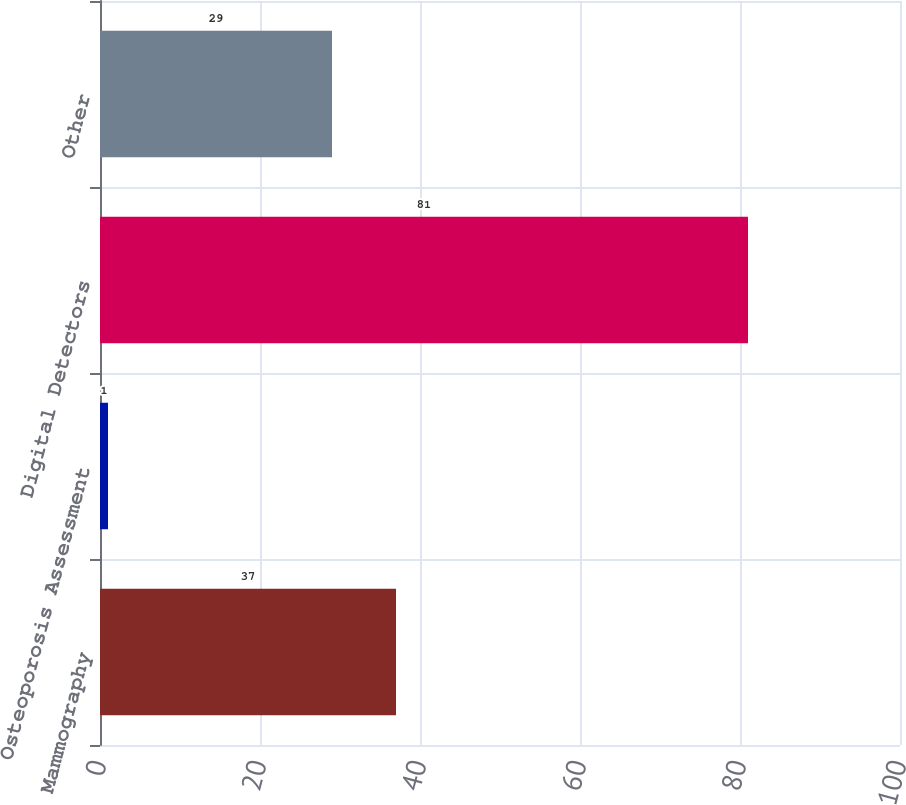Convert chart to OTSL. <chart><loc_0><loc_0><loc_500><loc_500><bar_chart><fcel>Mammography<fcel>Osteoporosis Assessment<fcel>Digital Detectors<fcel>Other<nl><fcel>37<fcel>1<fcel>81<fcel>29<nl></chart> 